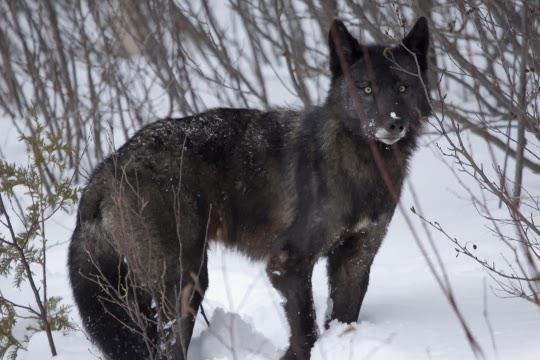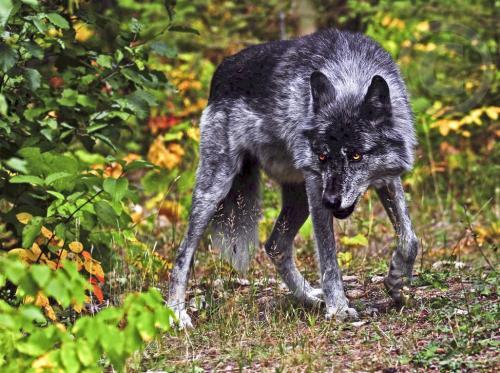The first image is the image on the left, the second image is the image on the right. Examine the images to the left and right. Is the description "There is exactly one animal in the image on the right." accurate? Answer yes or no. Yes. 